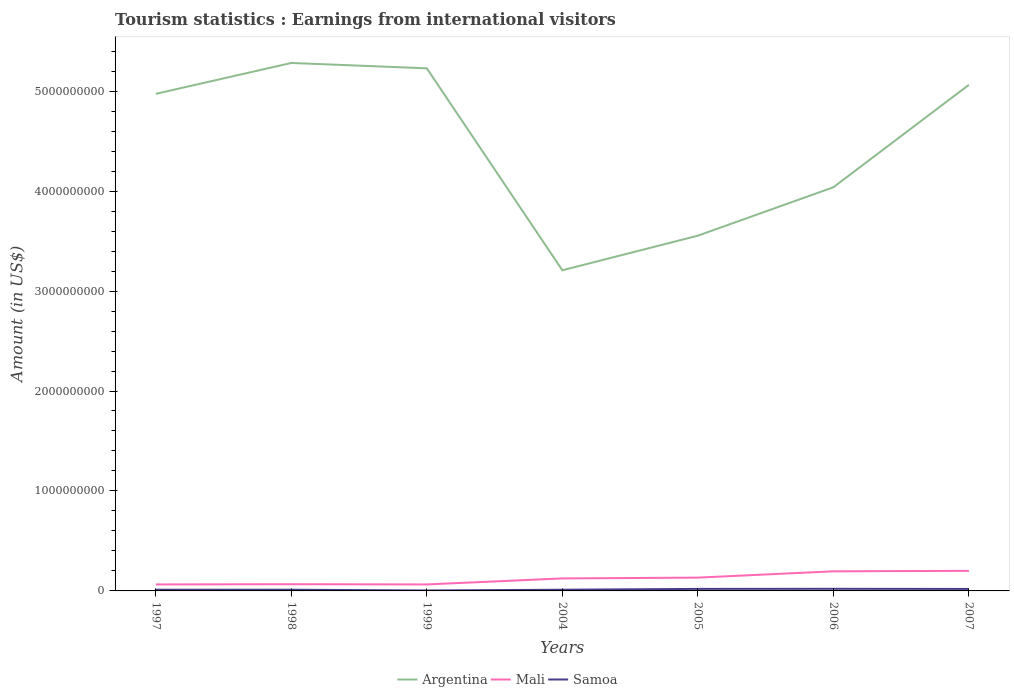Across all years, what is the maximum earnings from international visitors in Argentina?
Provide a succinct answer. 3.21e+09. In which year was the earnings from international visitors in Mali maximum?
Make the answer very short. 1997. What is the total earnings from international visitors in Mali in the graph?
Offer a terse response. -6.80e+07. What is the difference between the highest and the second highest earnings from international visitors in Argentina?
Your response must be concise. 2.07e+09. What is the difference between the highest and the lowest earnings from international visitors in Samoa?
Keep it short and to the point. 3. What is the difference between two consecutive major ticks on the Y-axis?
Make the answer very short. 1.00e+09. Does the graph contain grids?
Ensure brevity in your answer.  No. How many legend labels are there?
Your response must be concise. 3. What is the title of the graph?
Provide a succinct answer. Tourism statistics : Earnings from international visitors. Does "El Salvador" appear as one of the legend labels in the graph?
Your answer should be compact. No. What is the label or title of the X-axis?
Ensure brevity in your answer.  Years. What is the Amount (in US$) of Argentina in 1997?
Your response must be concise. 4.97e+09. What is the Amount (in US$) of Mali in 1997?
Your answer should be very brief. 6.50e+07. What is the Amount (in US$) of Argentina in 1998?
Provide a short and direct response. 5.28e+09. What is the Amount (in US$) of Mali in 1998?
Ensure brevity in your answer.  6.70e+07. What is the Amount (in US$) of Argentina in 1999?
Your answer should be very brief. 5.23e+09. What is the Amount (in US$) of Mali in 1999?
Keep it short and to the point. 6.50e+07. What is the Amount (in US$) in Samoa in 1999?
Your response must be concise. 4.40e+06. What is the Amount (in US$) in Argentina in 2004?
Your answer should be very brief. 3.21e+09. What is the Amount (in US$) of Mali in 2004?
Give a very brief answer. 1.25e+08. What is the Amount (in US$) in Argentina in 2005?
Give a very brief answer. 3.55e+09. What is the Amount (in US$) of Mali in 2005?
Ensure brevity in your answer.  1.33e+08. What is the Amount (in US$) in Samoa in 2005?
Provide a short and direct response. 2.03e+07. What is the Amount (in US$) in Argentina in 2006?
Provide a short and direct response. 4.04e+09. What is the Amount (in US$) of Mali in 2006?
Provide a short and direct response. 1.96e+08. What is the Amount (in US$) in Samoa in 2006?
Provide a succinct answer. 2.12e+07. What is the Amount (in US$) of Argentina in 2007?
Keep it short and to the point. 5.06e+09. What is the Amount (in US$) of Mali in 2007?
Provide a short and direct response. 2.01e+08. What is the Amount (in US$) in Samoa in 2007?
Make the answer very short. 1.98e+07. Across all years, what is the maximum Amount (in US$) in Argentina?
Offer a terse response. 5.28e+09. Across all years, what is the maximum Amount (in US$) of Mali?
Offer a terse response. 2.01e+08. Across all years, what is the maximum Amount (in US$) in Samoa?
Your answer should be very brief. 2.12e+07. Across all years, what is the minimum Amount (in US$) of Argentina?
Offer a very short reply. 3.21e+09. Across all years, what is the minimum Amount (in US$) of Mali?
Your answer should be very brief. 6.50e+07. Across all years, what is the minimum Amount (in US$) of Samoa?
Offer a very short reply. 4.40e+06. What is the total Amount (in US$) in Argentina in the graph?
Offer a very short reply. 3.13e+1. What is the total Amount (in US$) of Mali in the graph?
Ensure brevity in your answer.  8.52e+08. What is the total Amount (in US$) in Samoa in the graph?
Keep it short and to the point. 1.02e+08. What is the difference between the Amount (in US$) of Argentina in 1997 and that in 1998?
Provide a short and direct response. -3.09e+08. What is the difference between the Amount (in US$) of Argentina in 1997 and that in 1999?
Ensure brevity in your answer.  -2.55e+08. What is the difference between the Amount (in US$) in Mali in 1997 and that in 1999?
Keep it short and to the point. 0. What is the difference between the Amount (in US$) of Samoa in 1997 and that in 1999?
Offer a terse response. 7.60e+06. What is the difference between the Amount (in US$) in Argentina in 1997 and that in 2004?
Keep it short and to the point. 1.76e+09. What is the difference between the Amount (in US$) of Mali in 1997 and that in 2004?
Ensure brevity in your answer.  -6.00e+07. What is the difference between the Amount (in US$) of Argentina in 1997 and that in 2005?
Your response must be concise. 1.42e+09. What is the difference between the Amount (in US$) of Mali in 1997 and that in 2005?
Offer a very short reply. -6.80e+07. What is the difference between the Amount (in US$) of Samoa in 1997 and that in 2005?
Offer a very short reply. -8.30e+06. What is the difference between the Amount (in US$) of Argentina in 1997 and that in 2006?
Provide a succinct answer. 9.35e+08. What is the difference between the Amount (in US$) in Mali in 1997 and that in 2006?
Your answer should be compact. -1.31e+08. What is the difference between the Amount (in US$) of Samoa in 1997 and that in 2006?
Your answer should be very brief. -9.20e+06. What is the difference between the Amount (in US$) of Argentina in 1997 and that in 2007?
Ensure brevity in your answer.  -9.00e+07. What is the difference between the Amount (in US$) in Mali in 1997 and that in 2007?
Provide a short and direct response. -1.36e+08. What is the difference between the Amount (in US$) of Samoa in 1997 and that in 2007?
Offer a very short reply. -7.80e+06. What is the difference between the Amount (in US$) in Argentina in 1998 and that in 1999?
Your answer should be compact. 5.40e+07. What is the difference between the Amount (in US$) of Mali in 1998 and that in 1999?
Provide a succinct answer. 2.00e+06. What is the difference between the Amount (in US$) in Samoa in 1998 and that in 1999?
Provide a short and direct response. 7.60e+06. What is the difference between the Amount (in US$) in Argentina in 1998 and that in 2004?
Provide a succinct answer. 2.07e+09. What is the difference between the Amount (in US$) in Mali in 1998 and that in 2004?
Your answer should be very brief. -5.80e+07. What is the difference between the Amount (in US$) of Samoa in 1998 and that in 2004?
Ensure brevity in your answer.  0. What is the difference between the Amount (in US$) of Argentina in 1998 and that in 2005?
Give a very brief answer. 1.73e+09. What is the difference between the Amount (in US$) of Mali in 1998 and that in 2005?
Offer a terse response. -6.60e+07. What is the difference between the Amount (in US$) in Samoa in 1998 and that in 2005?
Your answer should be very brief. -8.30e+06. What is the difference between the Amount (in US$) in Argentina in 1998 and that in 2006?
Your answer should be very brief. 1.24e+09. What is the difference between the Amount (in US$) in Mali in 1998 and that in 2006?
Ensure brevity in your answer.  -1.29e+08. What is the difference between the Amount (in US$) of Samoa in 1998 and that in 2006?
Ensure brevity in your answer.  -9.20e+06. What is the difference between the Amount (in US$) of Argentina in 1998 and that in 2007?
Give a very brief answer. 2.19e+08. What is the difference between the Amount (in US$) of Mali in 1998 and that in 2007?
Your answer should be compact. -1.34e+08. What is the difference between the Amount (in US$) in Samoa in 1998 and that in 2007?
Make the answer very short. -7.80e+06. What is the difference between the Amount (in US$) of Argentina in 1999 and that in 2004?
Make the answer very short. 2.02e+09. What is the difference between the Amount (in US$) in Mali in 1999 and that in 2004?
Provide a short and direct response. -6.00e+07. What is the difference between the Amount (in US$) of Samoa in 1999 and that in 2004?
Keep it short and to the point. -7.60e+06. What is the difference between the Amount (in US$) of Argentina in 1999 and that in 2005?
Offer a very short reply. 1.67e+09. What is the difference between the Amount (in US$) of Mali in 1999 and that in 2005?
Provide a succinct answer. -6.80e+07. What is the difference between the Amount (in US$) in Samoa in 1999 and that in 2005?
Your answer should be very brief. -1.59e+07. What is the difference between the Amount (in US$) of Argentina in 1999 and that in 2006?
Your answer should be very brief. 1.19e+09. What is the difference between the Amount (in US$) in Mali in 1999 and that in 2006?
Keep it short and to the point. -1.31e+08. What is the difference between the Amount (in US$) in Samoa in 1999 and that in 2006?
Make the answer very short. -1.68e+07. What is the difference between the Amount (in US$) in Argentina in 1999 and that in 2007?
Keep it short and to the point. 1.65e+08. What is the difference between the Amount (in US$) in Mali in 1999 and that in 2007?
Offer a terse response. -1.36e+08. What is the difference between the Amount (in US$) of Samoa in 1999 and that in 2007?
Offer a very short reply. -1.54e+07. What is the difference between the Amount (in US$) in Argentina in 2004 and that in 2005?
Offer a terse response. -3.46e+08. What is the difference between the Amount (in US$) of Mali in 2004 and that in 2005?
Keep it short and to the point. -8.00e+06. What is the difference between the Amount (in US$) in Samoa in 2004 and that in 2005?
Give a very brief answer. -8.30e+06. What is the difference between the Amount (in US$) in Argentina in 2004 and that in 2006?
Provide a succinct answer. -8.30e+08. What is the difference between the Amount (in US$) in Mali in 2004 and that in 2006?
Keep it short and to the point. -7.10e+07. What is the difference between the Amount (in US$) of Samoa in 2004 and that in 2006?
Offer a terse response. -9.20e+06. What is the difference between the Amount (in US$) in Argentina in 2004 and that in 2007?
Your response must be concise. -1.86e+09. What is the difference between the Amount (in US$) in Mali in 2004 and that in 2007?
Your answer should be very brief. -7.60e+07. What is the difference between the Amount (in US$) of Samoa in 2004 and that in 2007?
Provide a succinct answer. -7.80e+06. What is the difference between the Amount (in US$) in Argentina in 2005 and that in 2006?
Provide a succinct answer. -4.84e+08. What is the difference between the Amount (in US$) in Mali in 2005 and that in 2006?
Offer a terse response. -6.30e+07. What is the difference between the Amount (in US$) in Samoa in 2005 and that in 2006?
Offer a very short reply. -9.00e+05. What is the difference between the Amount (in US$) of Argentina in 2005 and that in 2007?
Offer a very short reply. -1.51e+09. What is the difference between the Amount (in US$) of Mali in 2005 and that in 2007?
Offer a very short reply. -6.80e+07. What is the difference between the Amount (in US$) in Samoa in 2005 and that in 2007?
Your answer should be compact. 5.00e+05. What is the difference between the Amount (in US$) of Argentina in 2006 and that in 2007?
Give a very brief answer. -1.02e+09. What is the difference between the Amount (in US$) in Mali in 2006 and that in 2007?
Provide a succinct answer. -5.00e+06. What is the difference between the Amount (in US$) of Samoa in 2006 and that in 2007?
Provide a succinct answer. 1.40e+06. What is the difference between the Amount (in US$) in Argentina in 1997 and the Amount (in US$) in Mali in 1998?
Keep it short and to the point. 4.91e+09. What is the difference between the Amount (in US$) of Argentina in 1997 and the Amount (in US$) of Samoa in 1998?
Offer a very short reply. 4.96e+09. What is the difference between the Amount (in US$) in Mali in 1997 and the Amount (in US$) in Samoa in 1998?
Your answer should be compact. 5.30e+07. What is the difference between the Amount (in US$) in Argentina in 1997 and the Amount (in US$) in Mali in 1999?
Your response must be concise. 4.91e+09. What is the difference between the Amount (in US$) of Argentina in 1997 and the Amount (in US$) of Samoa in 1999?
Your answer should be very brief. 4.97e+09. What is the difference between the Amount (in US$) in Mali in 1997 and the Amount (in US$) in Samoa in 1999?
Provide a short and direct response. 6.06e+07. What is the difference between the Amount (in US$) of Argentina in 1997 and the Amount (in US$) of Mali in 2004?
Give a very brief answer. 4.85e+09. What is the difference between the Amount (in US$) in Argentina in 1997 and the Amount (in US$) in Samoa in 2004?
Your response must be concise. 4.96e+09. What is the difference between the Amount (in US$) in Mali in 1997 and the Amount (in US$) in Samoa in 2004?
Offer a terse response. 5.30e+07. What is the difference between the Amount (in US$) of Argentina in 1997 and the Amount (in US$) of Mali in 2005?
Your response must be concise. 4.84e+09. What is the difference between the Amount (in US$) of Argentina in 1997 and the Amount (in US$) of Samoa in 2005?
Keep it short and to the point. 4.95e+09. What is the difference between the Amount (in US$) in Mali in 1997 and the Amount (in US$) in Samoa in 2005?
Your answer should be compact. 4.47e+07. What is the difference between the Amount (in US$) in Argentina in 1997 and the Amount (in US$) in Mali in 2006?
Offer a terse response. 4.78e+09. What is the difference between the Amount (in US$) of Argentina in 1997 and the Amount (in US$) of Samoa in 2006?
Provide a succinct answer. 4.95e+09. What is the difference between the Amount (in US$) of Mali in 1997 and the Amount (in US$) of Samoa in 2006?
Make the answer very short. 4.38e+07. What is the difference between the Amount (in US$) of Argentina in 1997 and the Amount (in US$) of Mali in 2007?
Ensure brevity in your answer.  4.77e+09. What is the difference between the Amount (in US$) in Argentina in 1997 and the Amount (in US$) in Samoa in 2007?
Make the answer very short. 4.95e+09. What is the difference between the Amount (in US$) in Mali in 1997 and the Amount (in US$) in Samoa in 2007?
Provide a short and direct response. 4.52e+07. What is the difference between the Amount (in US$) of Argentina in 1998 and the Amount (in US$) of Mali in 1999?
Your response must be concise. 5.22e+09. What is the difference between the Amount (in US$) in Argentina in 1998 and the Amount (in US$) in Samoa in 1999?
Ensure brevity in your answer.  5.28e+09. What is the difference between the Amount (in US$) in Mali in 1998 and the Amount (in US$) in Samoa in 1999?
Keep it short and to the point. 6.26e+07. What is the difference between the Amount (in US$) in Argentina in 1998 and the Amount (in US$) in Mali in 2004?
Your answer should be compact. 5.16e+09. What is the difference between the Amount (in US$) in Argentina in 1998 and the Amount (in US$) in Samoa in 2004?
Your answer should be very brief. 5.27e+09. What is the difference between the Amount (in US$) in Mali in 1998 and the Amount (in US$) in Samoa in 2004?
Provide a succinct answer. 5.50e+07. What is the difference between the Amount (in US$) of Argentina in 1998 and the Amount (in US$) of Mali in 2005?
Your answer should be compact. 5.15e+09. What is the difference between the Amount (in US$) of Argentina in 1998 and the Amount (in US$) of Samoa in 2005?
Offer a very short reply. 5.26e+09. What is the difference between the Amount (in US$) in Mali in 1998 and the Amount (in US$) in Samoa in 2005?
Offer a terse response. 4.67e+07. What is the difference between the Amount (in US$) of Argentina in 1998 and the Amount (in US$) of Mali in 2006?
Your answer should be compact. 5.09e+09. What is the difference between the Amount (in US$) in Argentina in 1998 and the Amount (in US$) in Samoa in 2006?
Offer a terse response. 5.26e+09. What is the difference between the Amount (in US$) of Mali in 1998 and the Amount (in US$) of Samoa in 2006?
Your response must be concise. 4.58e+07. What is the difference between the Amount (in US$) in Argentina in 1998 and the Amount (in US$) in Mali in 2007?
Offer a very short reply. 5.08e+09. What is the difference between the Amount (in US$) in Argentina in 1998 and the Amount (in US$) in Samoa in 2007?
Ensure brevity in your answer.  5.26e+09. What is the difference between the Amount (in US$) in Mali in 1998 and the Amount (in US$) in Samoa in 2007?
Provide a succinct answer. 4.72e+07. What is the difference between the Amount (in US$) of Argentina in 1999 and the Amount (in US$) of Mali in 2004?
Make the answer very short. 5.10e+09. What is the difference between the Amount (in US$) in Argentina in 1999 and the Amount (in US$) in Samoa in 2004?
Give a very brief answer. 5.22e+09. What is the difference between the Amount (in US$) in Mali in 1999 and the Amount (in US$) in Samoa in 2004?
Provide a short and direct response. 5.30e+07. What is the difference between the Amount (in US$) of Argentina in 1999 and the Amount (in US$) of Mali in 2005?
Your answer should be compact. 5.10e+09. What is the difference between the Amount (in US$) of Argentina in 1999 and the Amount (in US$) of Samoa in 2005?
Your answer should be compact. 5.21e+09. What is the difference between the Amount (in US$) in Mali in 1999 and the Amount (in US$) in Samoa in 2005?
Ensure brevity in your answer.  4.47e+07. What is the difference between the Amount (in US$) in Argentina in 1999 and the Amount (in US$) in Mali in 2006?
Ensure brevity in your answer.  5.03e+09. What is the difference between the Amount (in US$) of Argentina in 1999 and the Amount (in US$) of Samoa in 2006?
Make the answer very short. 5.21e+09. What is the difference between the Amount (in US$) of Mali in 1999 and the Amount (in US$) of Samoa in 2006?
Provide a short and direct response. 4.38e+07. What is the difference between the Amount (in US$) in Argentina in 1999 and the Amount (in US$) in Mali in 2007?
Make the answer very short. 5.03e+09. What is the difference between the Amount (in US$) in Argentina in 1999 and the Amount (in US$) in Samoa in 2007?
Make the answer very short. 5.21e+09. What is the difference between the Amount (in US$) in Mali in 1999 and the Amount (in US$) in Samoa in 2007?
Ensure brevity in your answer.  4.52e+07. What is the difference between the Amount (in US$) of Argentina in 2004 and the Amount (in US$) of Mali in 2005?
Keep it short and to the point. 3.08e+09. What is the difference between the Amount (in US$) of Argentina in 2004 and the Amount (in US$) of Samoa in 2005?
Ensure brevity in your answer.  3.19e+09. What is the difference between the Amount (in US$) of Mali in 2004 and the Amount (in US$) of Samoa in 2005?
Offer a terse response. 1.05e+08. What is the difference between the Amount (in US$) in Argentina in 2004 and the Amount (in US$) in Mali in 2006?
Your answer should be very brief. 3.01e+09. What is the difference between the Amount (in US$) in Argentina in 2004 and the Amount (in US$) in Samoa in 2006?
Give a very brief answer. 3.19e+09. What is the difference between the Amount (in US$) in Mali in 2004 and the Amount (in US$) in Samoa in 2006?
Offer a very short reply. 1.04e+08. What is the difference between the Amount (in US$) in Argentina in 2004 and the Amount (in US$) in Mali in 2007?
Give a very brief answer. 3.01e+09. What is the difference between the Amount (in US$) of Argentina in 2004 and the Amount (in US$) of Samoa in 2007?
Provide a short and direct response. 3.19e+09. What is the difference between the Amount (in US$) in Mali in 2004 and the Amount (in US$) in Samoa in 2007?
Your answer should be compact. 1.05e+08. What is the difference between the Amount (in US$) of Argentina in 2005 and the Amount (in US$) of Mali in 2006?
Make the answer very short. 3.36e+09. What is the difference between the Amount (in US$) of Argentina in 2005 and the Amount (in US$) of Samoa in 2006?
Make the answer very short. 3.53e+09. What is the difference between the Amount (in US$) of Mali in 2005 and the Amount (in US$) of Samoa in 2006?
Ensure brevity in your answer.  1.12e+08. What is the difference between the Amount (in US$) of Argentina in 2005 and the Amount (in US$) of Mali in 2007?
Make the answer very short. 3.35e+09. What is the difference between the Amount (in US$) in Argentina in 2005 and the Amount (in US$) in Samoa in 2007?
Your answer should be very brief. 3.53e+09. What is the difference between the Amount (in US$) of Mali in 2005 and the Amount (in US$) of Samoa in 2007?
Your response must be concise. 1.13e+08. What is the difference between the Amount (in US$) in Argentina in 2006 and the Amount (in US$) in Mali in 2007?
Offer a terse response. 3.84e+09. What is the difference between the Amount (in US$) of Argentina in 2006 and the Amount (in US$) of Samoa in 2007?
Make the answer very short. 4.02e+09. What is the difference between the Amount (in US$) of Mali in 2006 and the Amount (in US$) of Samoa in 2007?
Your answer should be very brief. 1.76e+08. What is the average Amount (in US$) of Argentina per year?
Make the answer very short. 4.48e+09. What is the average Amount (in US$) of Mali per year?
Your answer should be compact. 1.22e+08. What is the average Amount (in US$) in Samoa per year?
Give a very brief answer. 1.45e+07. In the year 1997, what is the difference between the Amount (in US$) in Argentina and Amount (in US$) in Mali?
Provide a short and direct response. 4.91e+09. In the year 1997, what is the difference between the Amount (in US$) in Argentina and Amount (in US$) in Samoa?
Your answer should be very brief. 4.96e+09. In the year 1997, what is the difference between the Amount (in US$) in Mali and Amount (in US$) in Samoa?
Offer a terse response. 5.30e+07. In the year 1998, what is the difference between the Amount (in US$) in Argentina and Amount (in US$) in Mali?
Provide a short and direct response. 5.22e+09. In the year 1998, what is the difference between the Amount (in US$) of Argentina and Amount (in US$) of Samoa?
Keep it short and to the point. 5.27e+09. In the year 1998, what is the difference between the Amount (in US$) of Mali and Amount (in US$) of Samoa?
Keep it short and to the point. 5.50e+07. In the year 1999, what is the difference between the Amount (in US$) of Argentina and Amount (in US$) of Mali?
Offer a terse response. 5.16e+09. In the year 1999, what is the difference between the Amount (in US$) in Argentina and Amount (in US$) in Samoa?
Offer a terse response. 5.22e+09. In the year 1999, what is the difference between the Amount (in US$) in Mali and Amount (in US$) in Samoa?
Your answer should be compact. 6.06e+07. In the year 2004, what is the difference between the Amount (in US$) in Argentina and Amount (in US$) in Mali?
Your answer should be compact. 3.08e+09. In the year 2004, what is the difference between the Amount (in US$) of Argentina and Amount (in US$) of Samoa?
Keep it short and to the point. 3.20e+09. In the year 2004, what is the difference between the Amount (in US$) in Mali and Amount (in US$) in Samoa?
Ensure brevity in your answer.  1.13e+08. In the year 2005, what is the difference between the Amount (in US$) in Argentina and Amount (in US$) in Mali?
Provide a succinct answer. 3.42e+09. In the year 2005, what is the difference between the Amount (in US$) of Argentina and Amount (in US$) of Samoa?
Ensure brevity in your answer.  3.53e+09. In the year 2005, what is the difference between the Amount (in US$) in Mali and Amount (in US$) in Samoa?
Your answer should be very brief. 1.13e+08. In the year 2006, what is the difference between the Amount (in US$) in Argentina and Amount (in US$) in Mali?
Make the answer very short. 3.84e+09. In the year 2006, what is the difference between the Amount (in US$) in Argentina and Amount (in US$) in Samoa?
Provide a short and direct response. 4.02e+09. In the year 2006, what is the difference between the Amount (in US$) of Mali and Amount (in US$) of Samoa?
Offer a terse response. 1.75e+08. In the year 2007, what is the difference between the Amount (in US$) in Argentina and Amount (in US$) in Mali?
Your answer should be compact. 4.86e+09. In the year 2007, what is the difference between the Amount (in US$) of Argentina and Amount (in US$) of Samoa?
Offer a very short reply. 5.04e+09. In the year 2007, what is the difference between the Amount (in US$) of Mali and Amount (in US$) of Samoa?
Give a very brief answer. 1.81e+08. What is the ratio of the Amount (in US$) of Argentina in 1997 to that in 1998?
Your response must be concise. 0.94. What is the ratio of the Amount (in US$) of Mali in 1997 to that in 1998?
Provide a succinct answer. 0.97. What is the ratio of the Amount (in US$) in Argentina in 1997 to that in 1999?
Your answer should be compact. 0.95. What is the ratio of the Amount (in US$) in Samoa in 1997 to that in 1999?
Keep it short and to the point. 2.73. What is the ratio of the Amount (in US$) in Argentina in 1997 to that in 2004?
Offer a very short reply. 1.55. What is the ratio of the Amount (in US$) in Mali in 1997 to that in 2004?
Offer a terse response. 0.52. What is the ratio of the Amount (in US$) in Samoa in 1997 to that in 2004?
Ensure brevity in your answer.  1. What is the ratio of the Amount (in US$) in Argentina in 1997 to that in 2005?
Your answer should be very brief. 1.4. What is the ratio of the Amount (in US$) of Mali in 1997 to that in 2005?
Your answer should be very brief. 0.49. What is the ratio of the Amount (in US$) of Samoa in 1997 to that in 2005?
Offer a terse response. 0.59. What is the ratio of the Amount (in US$) of Argentina in 1997 to that in 2006?
Your answer should be compact. 1.23. What is the ratio of the Amount (in US$) in Mali in 1997 to that in 2006?
Keep it short and to the point. 0.33. What is the ratio of the Amount (in US$) in Samoa in 1997 to that in 2006?
Ensure brevity in your answer.  0.57. What is the ratio of the Amount (in US$) of Argentina in 1997 to that in 2007?
Provide a succinct answer. 0.98. What is the ratio of the Amount (in US$) of Mali in 1997 to that in 2007?
Your answer should be compact. 0.32. What is the ratio of the Amount (in US$) of Samoa in 1997 to that in 2007?
Make the answer very short. 0.61. What is the ratio of the Amount (in US$) of Argentina in 1998 to that in 1999?
Your answer should be compact. 1.01. What is the ratio of the Amount (in US$) in Mali in 1998 to that in 1999?
Your response must be concise. 1.03. What is the ratio of the Amount (in US$) of Samoa in 1998 to that in 1999?
Offer a terse response. 2.73. What is the ratio of the Amount (in US$) in Argentina in 1998 to that in 2004?
Ensure brevity in your answer.  1.65. What is the ratio of the Amount (in US$) of Mali in 1998 to that in 2004?
Your answer should be very brief. 0.54. What is the ratio of the Amount (in US$) in Samoa in 1998 to that in 2004?
Provide a succinct answer. 1. What is the ratio of the Amount (in US$) of Argentina in 1998 to that in 2005?
Ensure brevity in your answer.  1.49. What is the ratio of the Amount (in US$) of Mali in 1998 to that in 2005?
Ensure brevity in your answer.  0.5. What is the ratio of the Amount (in US$) of Samoa in 1998 to that in 2005?
Make the answer very short. 0.59. What is the ratio of the Amount (in US$) in Argentina in 1998 to that in 2006?
Offer a terse response. 1.31. What is the ratio of the Amount (in US$) in Mali in 1998 to that in 2006?
Provide a succinct answer. 0.34. What is the ratio of the Amount (in US$) of Samoa in 1998 to that in 2006?
Keep it short and to the point. 0.57. What is the ratio of the Amount (in US$) in Argentina in 1998 to that in 2007?
Your answer should be compact. 1.04. What is the ratio of the Amount (in US$) of Mali in 1998 to that in 2007?
Offer a very short reply. 0.33. What is the ratio of the Amount (in US$) of Samoa in 1998 to that in 2007?
Offer a terse response. 0.61. What is the ratio of the Amount (in US$) of Argentina in 1999 to that in 2004?
Keep it short and to the point. 1.63. What is the ratio of the Amount (in US$) in Mali in 1999 to that in 2004?
Provide a succinct answer. 0.52. What is the ratio of the Amount (in US$) of Samoa in 1999 to that in 2004?
Give a very brief answer. 0.37. What is the ratio of the Amount (in US$) in Argentina in 1999 to that in 2005?
Your answer should be very brief. 1.47. What is the ratio of the Amount (in US$) in Mali in 1999 to that in 2005?
Your answer should be very brief. 0.49. What is the ratio of the Amount (in US$) in Samoa in 1999 to that in 2005?
Offer a terse response. 0.22. What is the ratio of the Amount (in US$) of Argentina in 1999 to that in 2006?
Give a very brief answer. 1.29. What is the ratio of the Amount (in US$) in Mali in 1999 to that in 2006?
Your answer should be compact. 0.33. What is the ratio of the Amount (in US$) in Samoa in 1999 to that in 2006?
Offer a terse response. 0.21. What is the ratio of the Amount (in US$) of Argentina in 1999 to that in 2007?
Ensure brevity in your answer.  1.03. What is the ratio of the Amount (in US$) of Mali in 1999 to that in 2007?
Give a very brief answer. 0.32. What is the ratio of the Amount (in US$) of Samoa in 1999 to that in 2007?
Ensure brevity in your answer.  0.22. What is the ratio of the Amount (in US$) in Argentina in 2004 to that in 2005?
Give a very brief answer. 0.9. What is the ratio of the Amount (in US$) of Mali in 2004 to that in 2005?
Offer a terse response. 0.94. What is the ratio of the Amount (in US$) in Samoa in 2004 to that in 2005?
Offer a terse response. 0.59. What is the ratio of the Amount (in US$) in Argentina in 2004 to that in 2006?
Your response must be concise. 0.79. What is the ratio of the Amount (in US$) of Mali in 2004 to that in 2006?
Your response must be concise. 0.64. What is the ratio of the Amount (in US$) in Samoa in 2004 to that in 2006?
Offer a terse response. 0.57. What is the ratio of the Amount (in US$) of Argentina in 2004 to that in 2007?
Your answer should be compact. 0.63. What is the ratio of the Amount (in US$) in Mali in 2004 to that in 2007?
Your answer should be very brief. 0.62. What is the ratio of the Amount (in US$) in Samoa in 2004 to that in 2007?
Provide a short and direct response. 0.61. What is the ratio of the Amount (in US$) in Argentina in 2005 to that in 2006?
Your response must be concise. 0.88. What is the ratio of the Amount (in US$) of Mali in 2005 to that in 2006?
Offer a very short reply. 0.68. What is the ratio of the Amount (in US$) of Samoa in 2005 to that in 2006?
Keep it short and to the point. 0.96. What is the ratio of the Amount (in US$) in Argentina in 2005 to that in 2007?
Your response must be concise. 0.7. What is the ratio of the Amount (in US$) of Mali in 2005 to that in 2007?
Your response must be concise. 0.66. What is the ratio of the Amount (in US$) in Samoa in 2005 to that in 2007?
Your answer should be compact. 1.03. What is the ratio of the Amount (in US$) in Argentina in 2006 to that in 2007?
Provide a short and direct response. 0.8. What is the ratio of the Amount (in US$) in Mali in 2006 to that in 2007?
Make the answer very short. 0.98. What is the ratio of the Amount (in US$) in Samoa in 2006 to that in 2007?
Your answer should be compact. 1.07. What is the difference between the highest and the second highest Amount (in US$) of Argentina?
Keep it short and to the point. 5.40e+07. What is the difference between the highest and the lowest Amount (in US$) of Argentina?
Ensure brevity in your answer.  2.07e+09. What is the difference between the highest and the lowest Amount (in US$) of Mali?
Your answer should be compact. 1.36e+08. What is the difference between the highest and the lowest Amount (in US$) in Samoa?
Your response must be concise. 1.68e+07. 